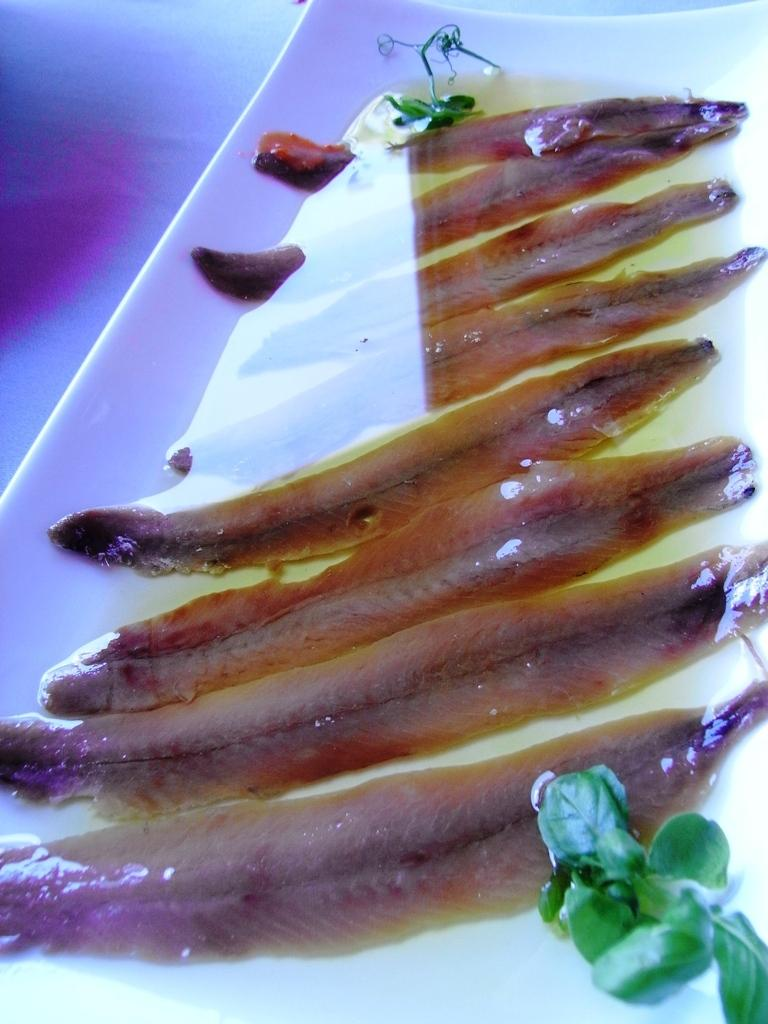What type of animals can be seen in the image? There are fishes in the image. Where are the fishes located? The fishes are in the water. What can be seen in the front of the image? There are leaves in the front of the image. How does the image compare to a mountain landscape? The image does not depict a mountain landscape; it features fishes in the water and leaves in the front. 